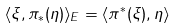Convert formula to latex. <formula><loc_0><loc_0><loc_500><loc_500>\langle \xi , \pi _ { * } ( \eta ) \rangle _ { E } = \langle \pi ^ { * } ( \xi ) , \eta \rangle</formula> 